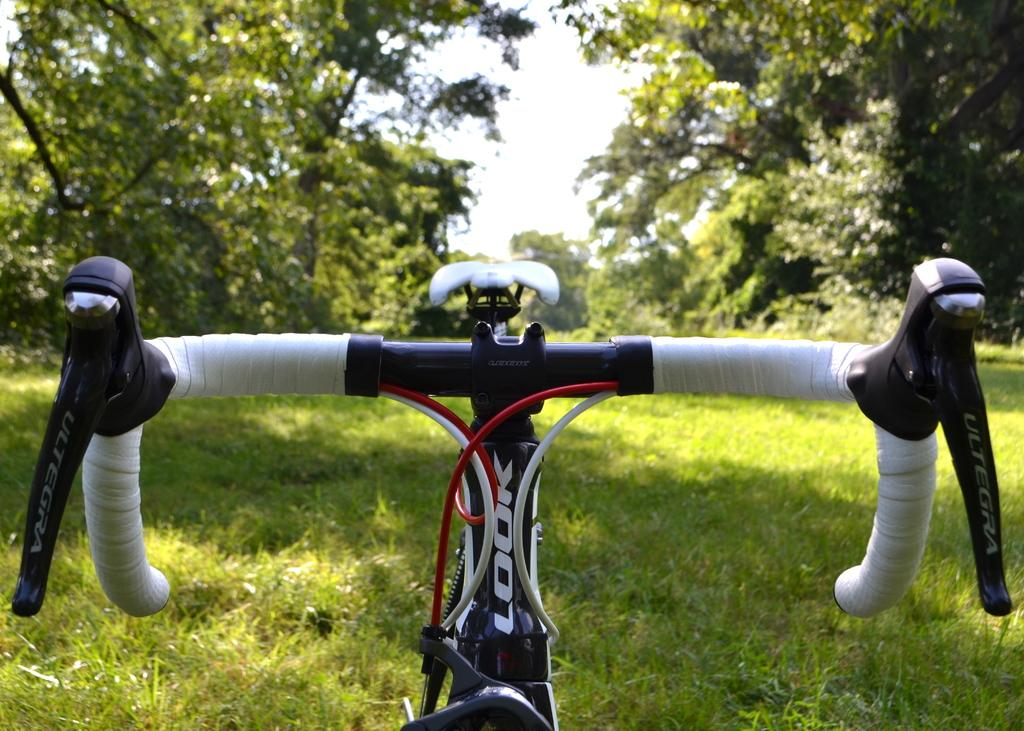What type of setting is depicted in the image? The image is an outside view. What object can be seen at the bottom of the image? There is a bicycle at the bottom of the image. What type of vegetation is visible on the ground? Grass is visible on the ground. What can be seen in the background of the image? There are many trees in the background. What is visible at the top of the image? The sky is visible at the top of the image. Where is the slave located in the image? There is no slave present in the image. What type of underwear can be seen hanging on the trees in the background? There are no underwear visible in the image; only trees are present in the background. 